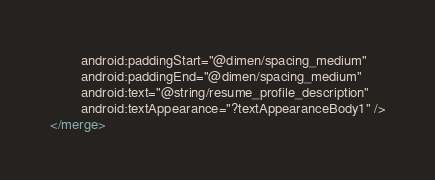<code> <loc_0><loc_0><loc_500><loc_500><_XML_>        android:paddingStart="@dimen/spacing_medium"
        android:paddingEnd="@dimen/spacing_medium"
        android:text="@string/resume_profile_description"
        android:textAppearance="?textAppearanceBody1" />
</merge>
</code> 